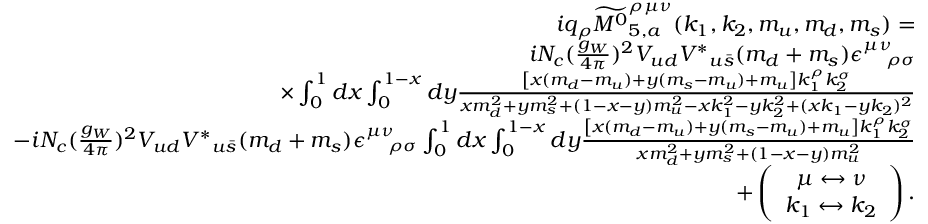<formula> <loc_0><loc_0><loc_500><loc_500>\begin{array} { r l r } & { i q _ { \rho } \widetilde { { M ^ { 0 } } } _ { 5 , a } ^ { \rho \mu \nu } ( k _ { 1 } , k _ { 2 } , m _ { u } , m _ { d } , m _ { s } ) = } \\ & { i N _ { c } ( \frac { g _ { W } } { 4 \pi } ) ^ { 2 } V _ { u d } { V ^ { \ast } } _ { u \bar { s } } ( m _ { d } + m _ { s } ) \epsilon _ { \quad \rho \sigma } ^ { \mu \nu } } \\ & { \times \int _ { 0 } ^ { 1 } d x \int _ { 0 } ^ { 1 - x } d y \frac { \left [ x ( m _ { d } - m _ { u } ) + y ( m _ { s } - m _ { u } ) + m _ { u } \right ] k _ { 1 } ^ { \rho } k _ { 2 } ^ { \sigma } } { x m _ { d } ^ { 2 } + y m _ { s } ^ { 2 } + ( 1 - x - y ) m _ { u } ^ { 2 } - x k _ { 1 } ^ { 2 } - y k _ { 2 } ^ { 2 } + ( x k _ { 1 } - y k _ { 2 } ) ^ { 2 } } } \\ & { - i N _ { c } ( \frac { g _ { W } } { 4 \pi } ) ^ { 2 } V _ { u d } { V ^ { \ast } } _ { u \bar { s } } ( m _ { d } + m _ { s } ) \epsilon _ { \quad \rho \sigma } ^ { \mu \nu } \int _ { 0 } ^ { 1 } d x \int _ { 0 } ^ { 1 - x } d y \frac { \left [ x ( m _ { d } - m _ { u } ) + y ( m _ { s } - m _ { u } ) + m _ { u } \right ] k _ { 1 } ^ { \rho } k _ { 2 } ^ { \sigma } } { x m _ { d } ^ { 2 } + y m _ { s } ^ { 2 } + ( 1 - x - y ) m _ { u } ^ { 2 } } } \\ & { + \left ( \begin{array} { c } { \mu \leftrightarrow \nu } \\ { k _ { 1 } \leftrightarrow k _ { 2 } } \end{array} \right ) . } \end{array}</formula> 